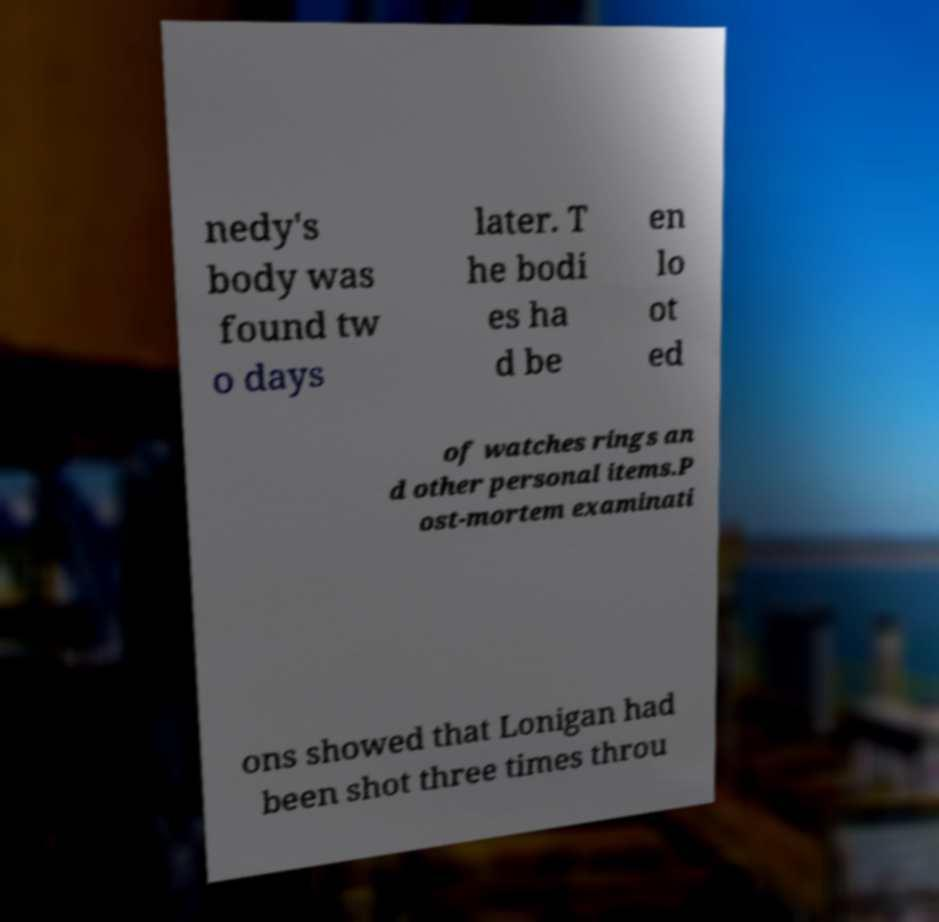Can you accurately transcribe the text from the provided image for me? nedy's body was found tw o days later. T he bodi es ha d be en lo ot ed of watches rings an d other personal items.P ost-mortem examinati ons showed that Lonigan had been shot three times throu 